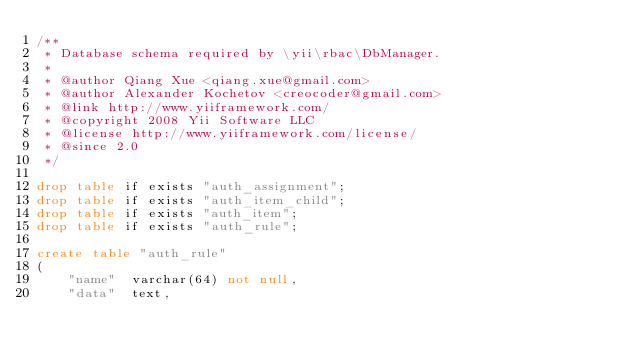Convert code to text. <code><loc_0><loc_0><loc_500><loc_500><_SQL_>/**
 * Database schema required by \yii\rbac\DbManager.
 *
 * @author Qiang Xue <qiang.xue@gmail.com>
 * @author Alexander Kochetov <creocoder@gmail.com>
 * @link http://www.yiiframework.com/
 * @copyright 2008 Yii Software LLC
 * @license http://www.yiiframework.com/license/
 * @since 2.0
 */

drop table if exists "auth_assignment";
drop table if exists "auth_item_child";
drop table if exists "auth_item";
drop table if exists "auth_rule";

create table "auth_rule"
(
    "name"  varchar(64) not null,
    "data"  text,</code> 